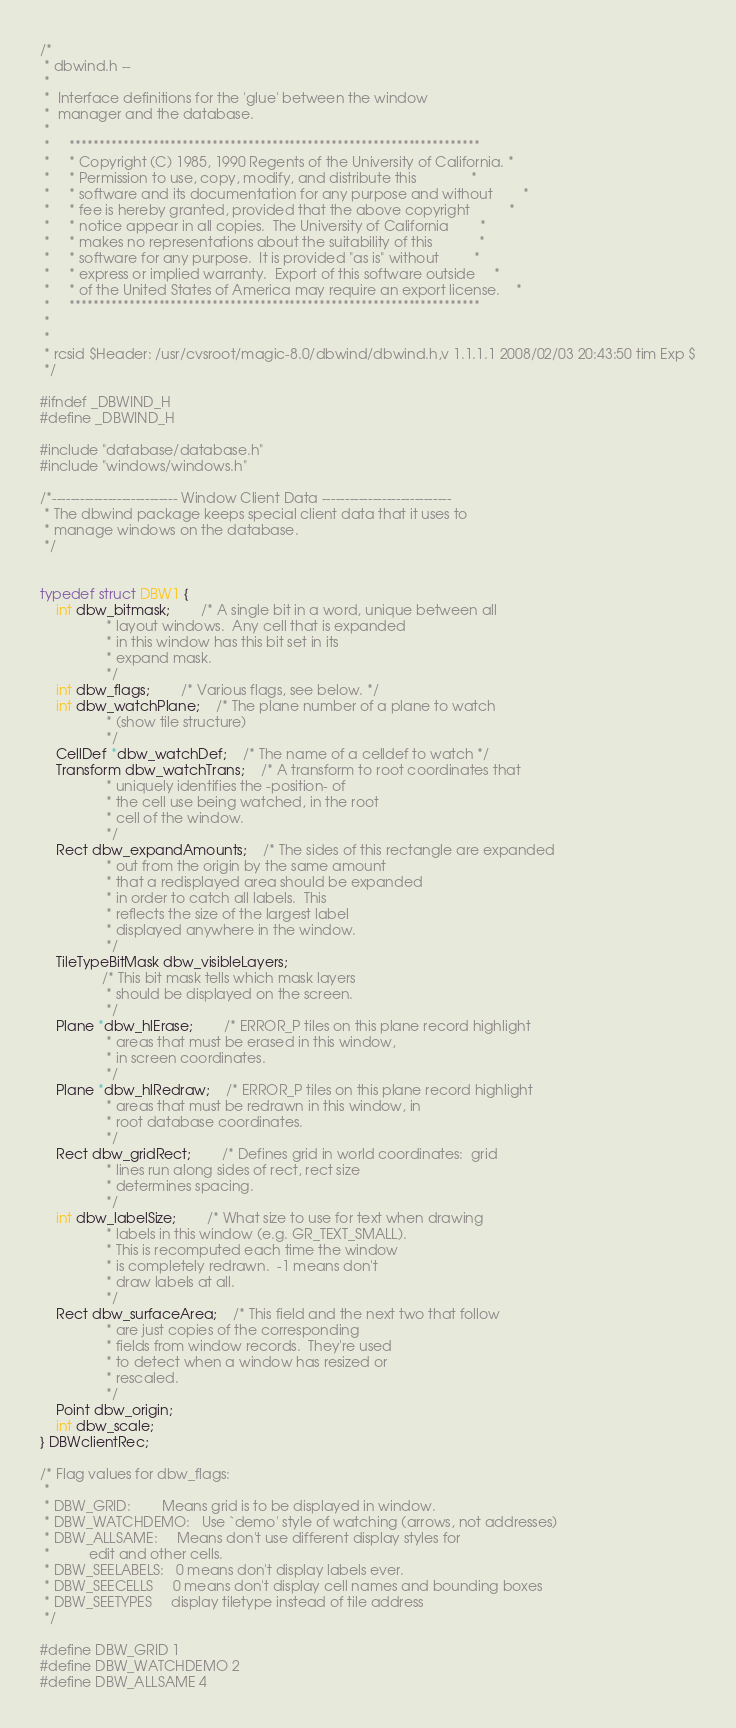<code> <loc_0><loc_0><loc_500><loc_500><_C_>/*
 * dbwind.h --
 *
 *	Interface definitions for the 'glue' between the window
 *	manager and the database.
 *
 *     *********************************************************************
 *     * Copyright (C) 1985, 1990 Regents of the University of California. *
 *     * Permission to use, copy, modify, and distribute this              *
 *     * software and its documentation for any purpose and without        *
 *     * fee is hereby granted, provided that the above copyright          *
 *     * notice appear in all copies.  The University of California        *
 *     * makes no representations about the suitability of this            *
 *     * software for any purpose.  It is provided "as is" without         *
 *     * express or implied warranty.  Export of this software outside     *
 *     * of the United States of America may require an export license.    *
 *     *********************************************************************
 *
 *
 * rcsid $Header: /usr/cvsroot/magic-8.0/dbwind/dbwind.h,v 1.1.1.1 2008/02/03 20:43:50 tim Exp $
 */

#ifndef _DBWIND_H
#define _DBWIND_H

#include "database/database.h"
#include "windows/windows.h"

/*--------------------------- Window Client Data ----------------------------
 * The dbwind package keeps special client data that it uses to
 * manage windows on the database.
 */


typedef struct DBW1 {
    int dbw_bitmask;		/* A single bit in a word, unique between all
				 * layout windows.  Any cell that is expanded
				 * in this window has this bit set in its
				 * expand mask.
				 */
    int dbw_flags;		/* Various flags, see below. */
    int dbw_watchPlane; 	/* The plane number of a plane to watch
				 * (show tile structure)
				 */
    CellDef *dbw_watchDef;	/* The name of a celldef to watch */
    Transform dbw_watchTrans;	/* A transform to root coordinates that
				 * uniquely identifies the -position- of
				 * the cell use being watched, in the root
				 * cell of the window.
				 */
    Rect dbw_expandAmounts;	/* The sides of this rectangle are expanded
				 * out from the origin by the same amount
				 * that a redisplayed area should be expanded
				 * in order to catch all labels.  This
				 * reflects the size of the largest label
				 * displayed anywhere in the window.
				 */
    TileTypeBitMask dbw_visibleLayers;
				/* This bit mask tells which mask layers
				 * should be displayed on the screen.
				 */
    Plane *dbw_hlErase;		/* ERROR_P tiles on this plane record highlight
				 * areas that must be erased in this window,
				 * in screen coordinates.
				 */
    Plane *dbw_hlRedraw;	/* ERROR_P tiles on this plane record highlight
				 * areas that must be redrawn in this window, in
				 * root database coordinates.
				 */
    Rect dbw_gridRect;		/* Defines grid in world coordinates:  grid
				 * lines run along sides of rect, rect size
				 * determines spacing.
				 */
    int dbw_labelSize;		/* What size to use for text when drawing
				 * labels in this window (e.g. GR_TEXT_SMALL).
				 * This is recomputed each time the window
				 * is completely redrawn.  -1 means don't
				 * draw labels at all.
				 */
    Rect dbw_surfaceArea;	/* This field and the next two that follow
				 * are just copies of the corresponding
				 * fields from window records.  They're used
				 * to detect when a window has resized or
				 * rescaled.
				 */
    Point dbw_origin;
    int dbw_scale;
} DBWclientRec;

/* Flag values for dbw_flags:
 *
 * DBW_GRID:		Means grid is to be displayed in window.
 * DBW_WATCHDEMO:	Use `demo' style of watching (arrows, not addresses)
 * DBW_ALLSAME:		Means don't use different display styles for
 *			edit and other cells.
 * DBW_SEELABELS:	0 means don't display labels ever.
 * DBW_SEECELLS		0 means don't display cell names and bounding boxes
 * DBW_SEETYPES		display tiletype instead of tile address
 */

#define DBW_GRID 1
#define DBW_WATCHDEMO 2
#define DBW_ALLSAME 4</code> 